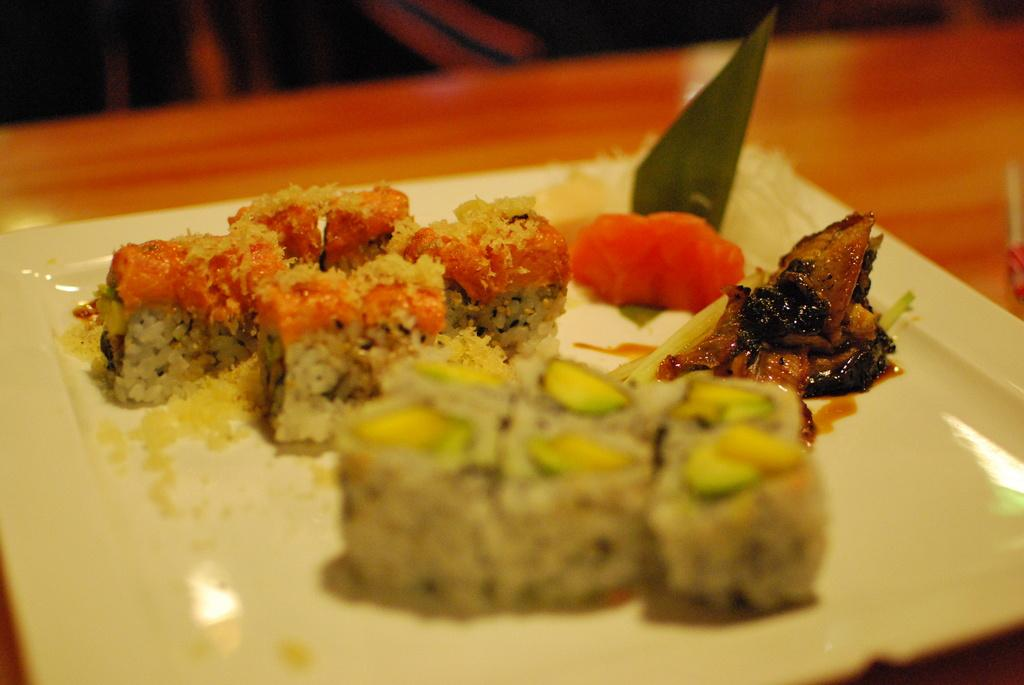What is on the plate that is visible in the image? There is food on the plate in the image. Where is the plate located in the image? The plate is placed on a table in the image. What type of tree can be seen in the bedroom in the image? There is no tree or bedroom present in the image; it only shows a plate of food on a table. 